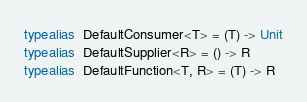<code> <loc_0><loc_0><loc_500><loc_500><_Kotlin_>typealias  DefaultConsumer<T> = (T) -> Unit
typealias  DefaultSupplier<R> = () -> R
typealias  DefaultFunction<T, R> = (T) -> R
</code> 